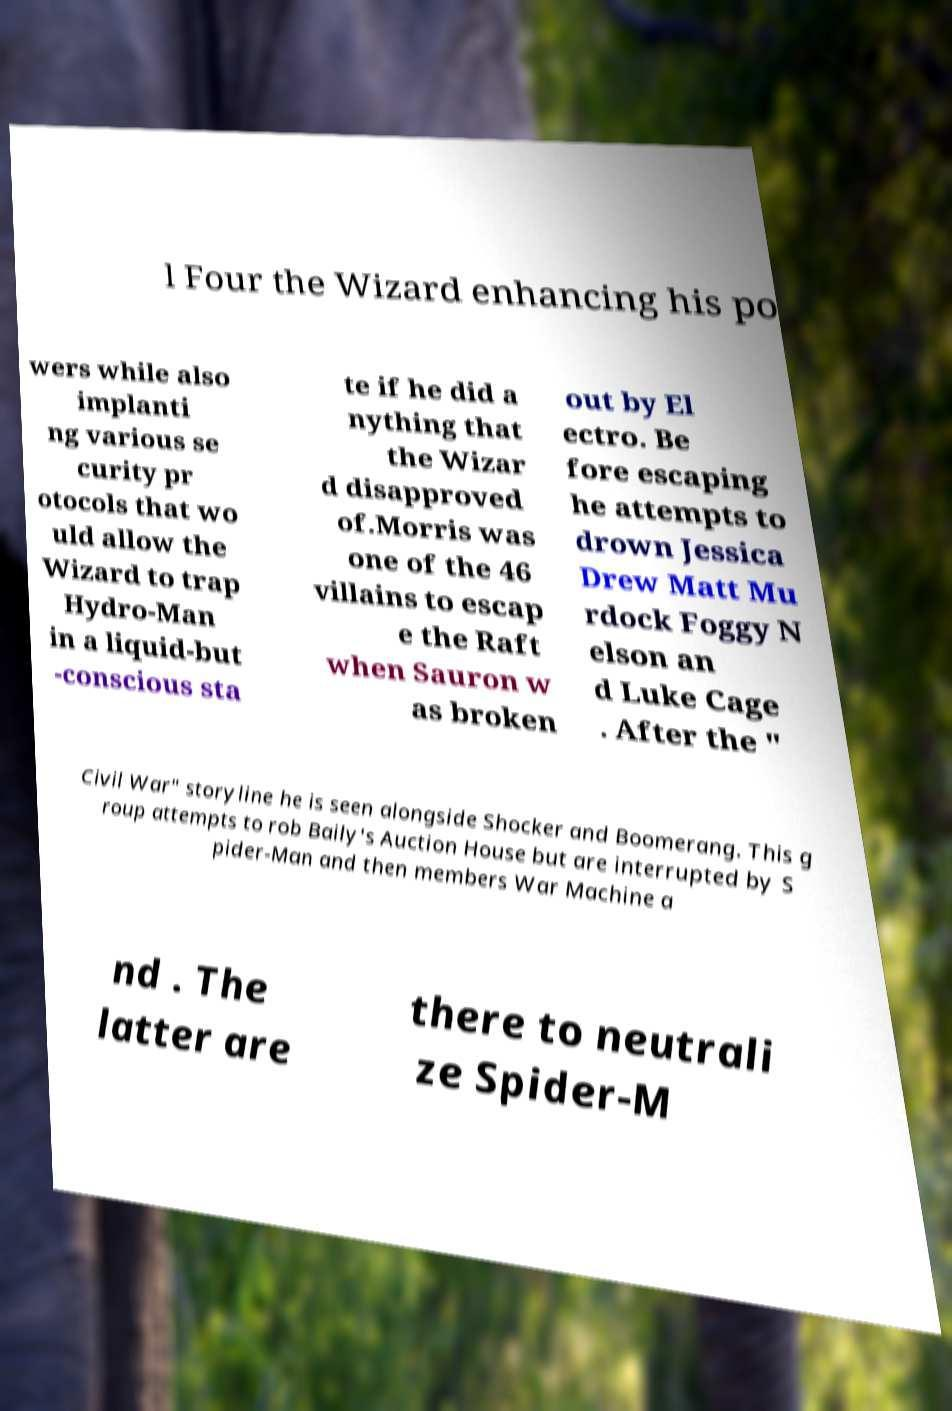I need the written content from this picture converted into text. Can you do that? l Four the Wizard enhancing his po wers while also implanti ng various se curity pr otocols that wo uld allow the Wizard to trap Hydro-Man in a liquid-but -conscious sta te if he did a nything that the Wizar d disapproved of.Morris was one of the 46 villains to escap e the Raft when Sauron w as broken out by El ectro. Be fore escaping he attempts to drown Jessica Drew Matt Mu rdock Foggy N elson an d Luke Cage . After the " Civil War" storyline he is seen alongside Shocker and Boomerang. This g roup attempts to rob Baily's Auction House but are interrupted by S pider-Man and then members War Machine a nd . The latter are there to neutrali ze Spider-M 